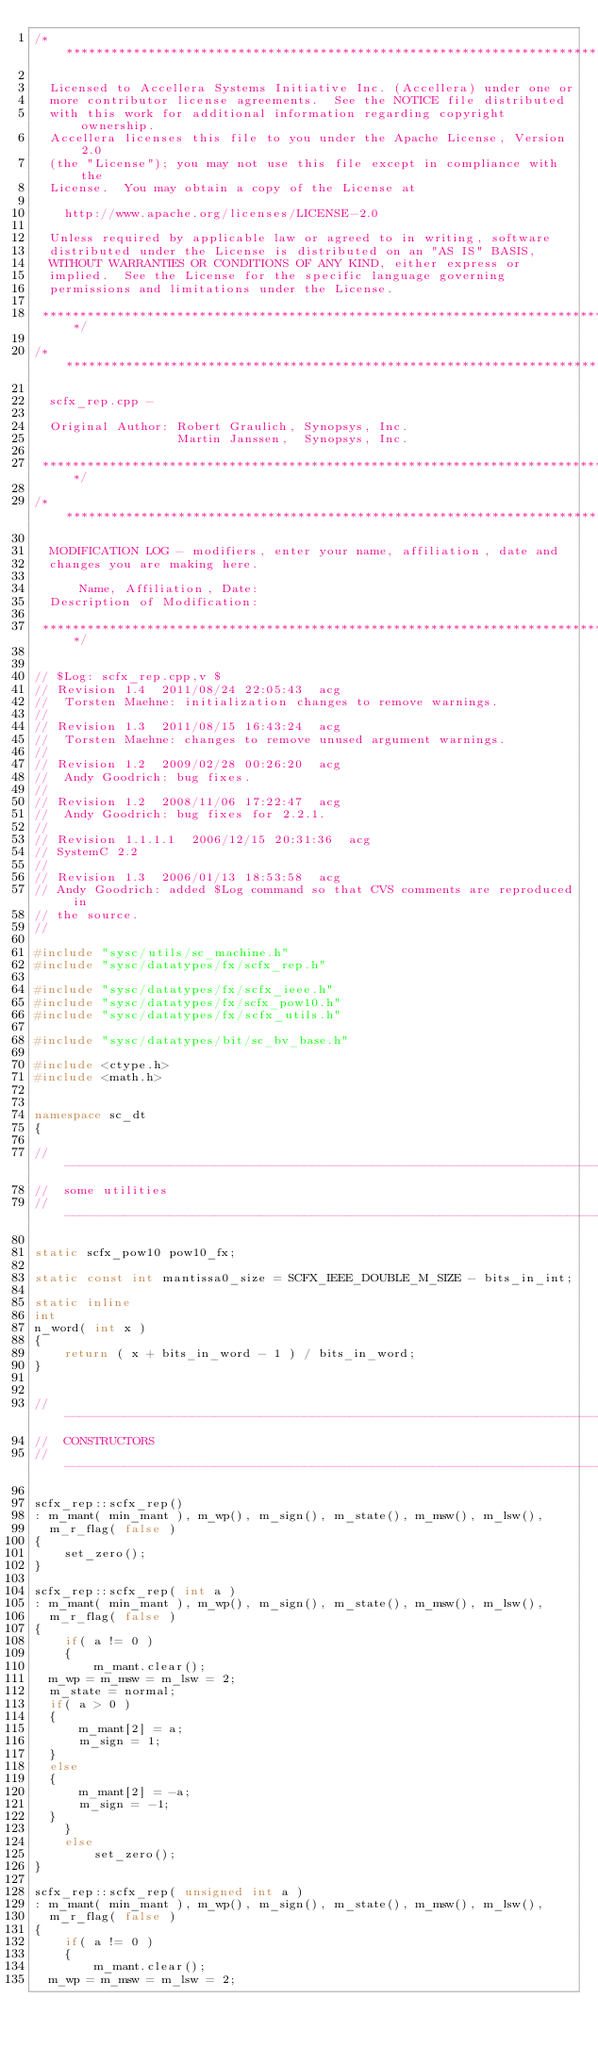Convert code to text. <code><loc_0><loc_0><loc_500><loc_500><_C++_>/*****************************************************************************

  Licensed to Accellera Systems Initiative Inc. (Accellera) under one or
  more contributor license agreements.  See the NOTICE file distributed
  with this work for additional information regarding copyright ownership.
  Accellera licenses this file to you under the Apache License, Version 2.0
  (the "License"); you may not use this file except in compliance with the
  License.  You may obtain a copy of the License at

    http://www.apache.org/licenses/LICENSE-2.0

  Unless required by applicable law or agreed to in writing, software
  distributed under the License is distributed on an "AS IS" BASIS,
  WITHOUT WARRANTIES OR CONDITIONS OF ANY KIND, either express or
  implied.  See the License for the specific language governing
  permissions and limitations under the License.

 *****************************************************************************/

/*****************************************************************************

  scfx_rep.cpp - 

  Original Author: Robert Graulich, Synopsys, Inc.
                   Martin Janssen,  Synopsys, Inc.

 *****************************************************************************/

/*****************************************************************************

  MODIFICATION LOG - modifiers, enter your name, affiliation, date and
  changes you are making here.

      Name, Affiliation, Date:
  Description of Modification:

 *****************************************************************************/


// $Log: scfx_rep.cpp,v $
// Revision 1.4  2011/08/24 22:05:43  acg
//  Torsten Maehne: initialization changes to remove warnings.
//
// Revision 1.3  2011/08/15 16:43:24  acg
//  Torsten Maehne: changes to remove unused argument warnings.
//
// Revision 1.2  2009/02/28 00:26:20  acg
//  Andy Goodrich: bug fixes.
//
// Revision 1.2  2008/11/06 17:22:47  acg
//  Andy Goodrich: bug fixes for 2.2.1.
//
// Revision 1.1.1.1  2006/12/15 20:31:36  acg
// SystemC 2.2
//
// Revision 1.3  2006/01/13 18:53:58  acg
// Andy Goodrich: added $Log command so that CVS comments are reproduced in
// the source.
//

#include "sysc/utils/sc_machine.h"
#include "sysc/datatypes/fx/scfx_rep.h"

#include "sysc/datatypes/fx/scfx_ieee.h"
#include "sysc/datatypes/fx/scfx_pow10.h"
#include "sysc/datatypes/fx/scfx_utils.h"

#include "sysc/datatypes/bit/sc_bv_base.h"

#include <ctype.h>
#include <math.h>


namespace sc_dt
{

// ----------------------------------------------------------------------------
//  some utilities
// ----------------------------------------------------------------------------

static scfx_pow10 pow10_fx;

static const int mantissa0_size = SCFX_IEEE_DOUBLE_M_SIZE - bits_in_int;

static inline
int
n_word( int x )
{
    return ( x + bits_in_word - 1 ) / bits_in_word;
}


// ----------------------------------------------------------------------------
//  CONSTRUCTORS
// ----------------------------------------------------------------------------

scfx_rep::scfx_rep()
: m_mant( min_mant ), m_wp(), m_sign(), m_state(), m_msw(), m_lsw(), 
  m_r_flag( false )
{
    set_zero();
}

scfx_rep::scfx_rep( int a )
: m_mant( min_mant ), m_wp(), m_sign(), m_state(), m_msw(), m_lsw(), 
  m_r_flag( false )
{
    if( a != 0 )
    {
        m_mant.clear();
	m_wp = m_msw = m_lsw = 2;
	m_state = normal;
	if( a > 0 )
	{
	    m_mant[2] = a;
	    m_sign = 1;
	}
	else
	{
	    m_mant[2] = -a;
	    m_sign = -1;
	}
    }
    else
        set_zero();
}

scfx_rep::scfx_rep( unsigned int a )
: m_mant( min_mant ), m_wp(), m_sign(), m_state(), m_msw(), m_lsw(), 
  m_r_flag( false )
{
    if( a != 0 )
    {
        m_mant.clear();
	m_wp = m_msw = m_lsw = 2;</code> 